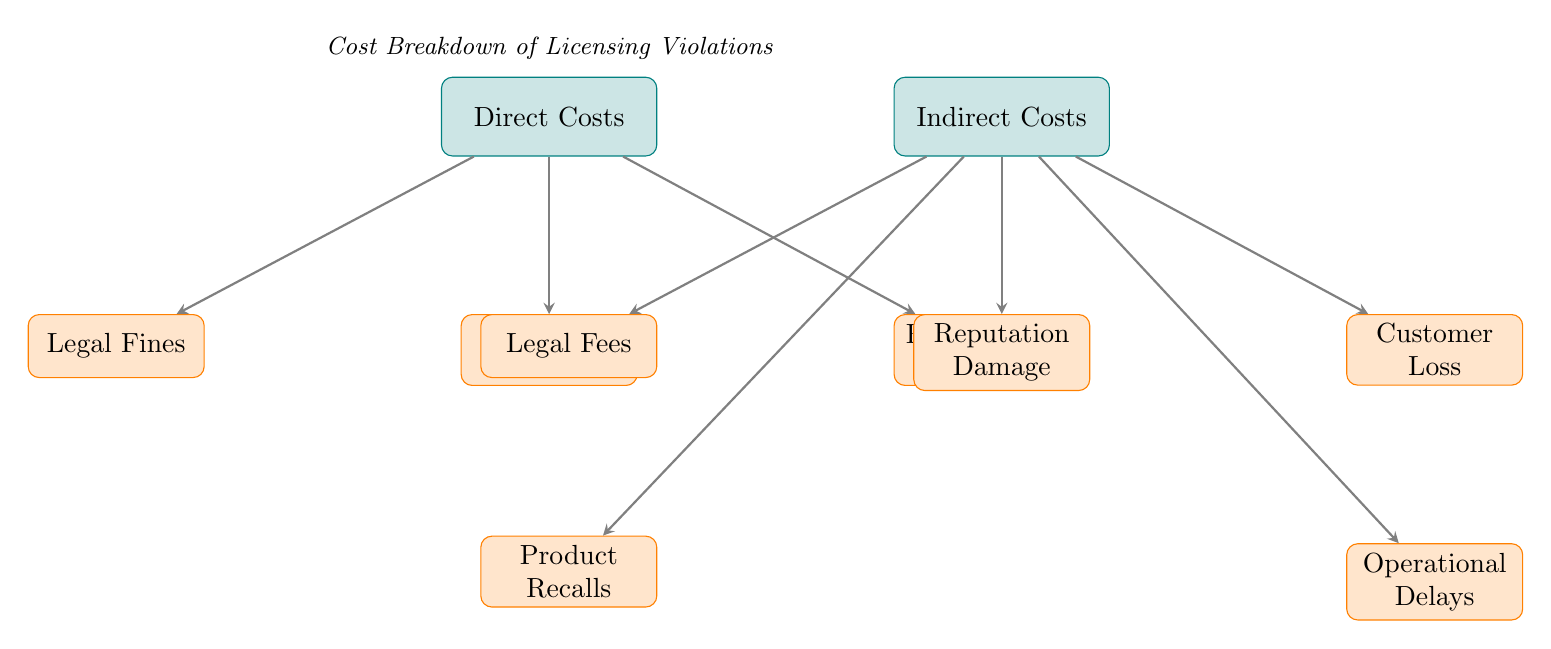What are the two main categories of costs presented in the diagram? The diagram categorizes costs into two main types: Direct Costs and Indirect Costs. These categories are labeled at the highest level of the diagram, clearly distinguishing between them.
Answer: Direct Costs and Indirect Costs How many subcategories are there under Direct Costs? Under the Direct Costs node, there are three subcategories: Legal Fines, Settlement Fees, and Remediation Costs. Counting these gives a total of three subcategories.
Answer: Three What cost is associated with legal implications under Indirect Costs? The cost associated with legal implications under Indirect Costs is Legal Fees. This subcategory is illustrated as a direct result of the indirect cost category of licensing violations.
Answer: Legal Fees What is the relationship between Indirect Costs and Reputation Damage? Reputation Damage is a subcategory that falls under Indirect Costs. The arrow connecting Indirect Costs to Reputation Damage illustrates that Reputation Damage is linked as a consequence of being classified under Indirect Costs.
Answer: It is a subcategory of Indirect Costs Which subcategory relates to customer issues? The subcategory relating to customer issues under Indirect Costs is Customer Loss. This node is specifically focused on the impact of licensing violations on customer retention and overall satisfaction.
Answer: Customer Loss What are the two subcategories linked to Legal Fees? Legal Fees links directly to Product Recalls and is seen as a cost associated with legal implications; however, no further subcategories under Legal Fees are stated in the diagram. Legal Fees is independent of any further divisions in this context.
Answer: Product Recalls and not further categorized Which category includes the settlement fees? Settlement Fees are included under Direct Costs. This is indicated by its placement as a subnode connected directly beneath the Direct Costs main node, showing its association as a direct financial consequence of licensing violations.
Answer: Direct Costs How are Operational Delays related to Indirect Costs? Operational Delays are a subcategory of Indirect Costs, which means they represent a consequence of licensing violations that lead to broader operational disruptions within a project. The diagram clearly delineates Operational Delays as part of the Indirect Costs consequences.
Answer: They are a subcategory of Indirect Costs 